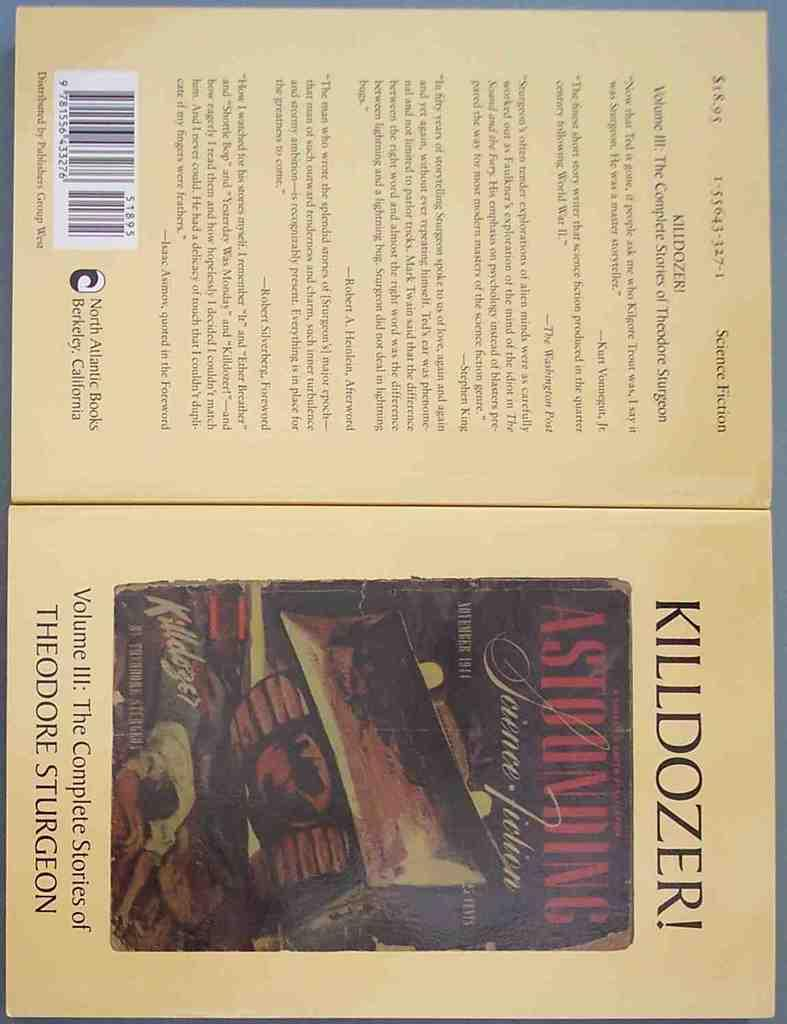<image>
Provide a brief description of the given image. The front and back cover to the book Killdozer. 